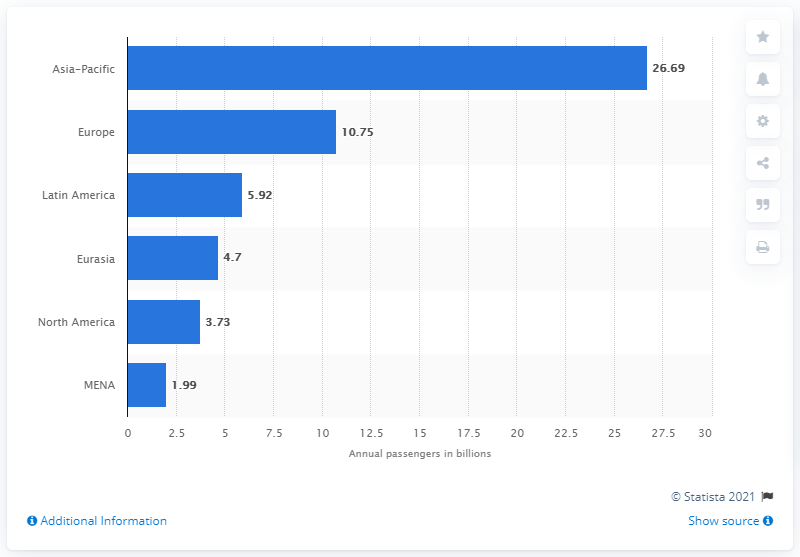Indicate a few pertinent items in this graphic. In 2017, the Asia-Pacific region had the highest ridership, indicating a high level of demand for public transportation services in the region. 